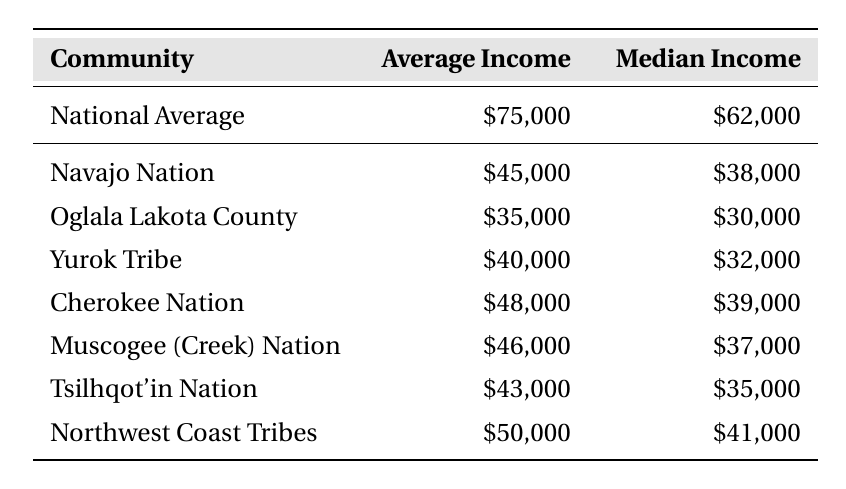What is the average household income of the Navajo Nation? The average household income for the Navajo Nation is explicitly listed in the table as $45,000.
Answer: $45,000 What is the median household income for the Oglala Lakota County? The median household income for Oglala Lakota County is provided in the table as $30,000.
Answer: $30,000 Which Indigenous community has the highest average household income? By comparing the average household incomes of each community listed, Northwest Coast Tribes has the highest average household income at $50,000.
Answer: Northwest Coast Tribes How much lower is the average household income of the Yurok Tribe compared to the national average? The average household income of the Yurok Tribe is $40,000, while the national average is $75,000. The difference is $75,000 - $40,000 = $35,000.
Answer: $35,000 What is the median household income difference between the Cherokee Nation and the national average? The median household income for the Cherokee Nation is $39,000 and for the national average it is $62,000. The difference is $62,000 - $39,000 = $23,000.
Answer: $23,000 Is the average household income of the Muscogee (Creek) Nation above or below the national average? The average household income for the Muscogee (Creek) Nation is $46,000, which is below the national average of $75,000.
Answer: Below How do the average household incomes of the Tsilhqot'in Nation and Yurok Tribe compare? The average household income for the Tsilhqot'in Nation is $43,000 and for the Yurok Tribe is $40,000. Tsilhqot'in Nation's income is higher by $3,000 ($43,000 - $40,000).
Answer: Tsilhqot'in Nation is higher by $3,000 What is the median income of Indigenous communities in the table? The median incomes for the Indigenous communities are $38,000 (Navajo Nation), $30,000 (Oglala Lakota County), $32,000 (Yurok Tribe), $39,000 (Cherokee Nation), $37,000 (Muscogee Nation), $35,000 (Tsilhqot'in Nation), and $41,000 (Northwest Coast Tribes). The sum is $38,000 + $30,000 + $32,000 + $39,000 + $37,000 + $35,000 + $41,000 = $252,000. There are 7 communities, so the median is $252,000/7 ≈ $36,000.
Answer: Approximately $36,000 What fraction of Indigenous communities have an average household income above $40,000? The communities with an average household income above $40,000 are the Northwest Coast Tribes ($50,000) and the Cherokee Nation ($48,000). There are 2 out of 7 communities that meet this criterion, so the fraction is 2/7.
Answer: 2/7 Which community has the closest average household income to the national median of $62,000? All the Indigenous communities listed have average household incomes that are significantly lower than the national median of $62,000. The closest one is the Northwest Coast Tribes at $50,000, which is $12,000 less than the national median.
Answer: Northwest Coast Tribes What percentage of the national average does the average household income from the Oglala Lakota County represent? The average household income of Oglala Lakota County is $35,000. The percentage of the national average ($75,000) is ($35,000 / $75,000) * 100 = 46.67%.
Answer: 46.67% 